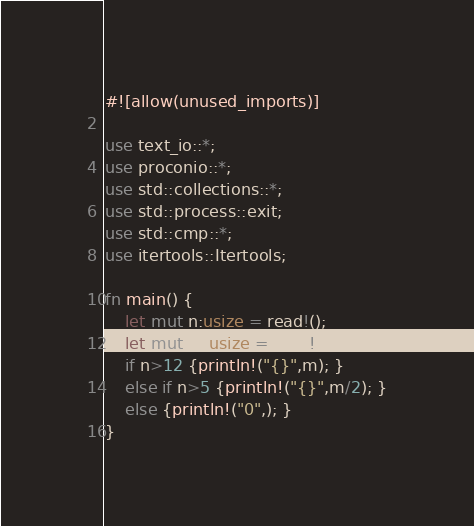Convert code to text. <code><loc_0><loc_0><loc_500><loc_500><_Rust_>#![allow(unused_imports)]

use text_io::*;
use proconio::*;
use std::collections::*;
use std::process::exit;
use std::cmp::*;
use itertools::Itertools;

fn main() {
    let mut n:usize = read!();
    let mut m:usize = read!();
    if n>12 {println!("{}",m); }
    else if n>5 {println!("{}",m/2); }
    else {println!("0",); }
}</code> 